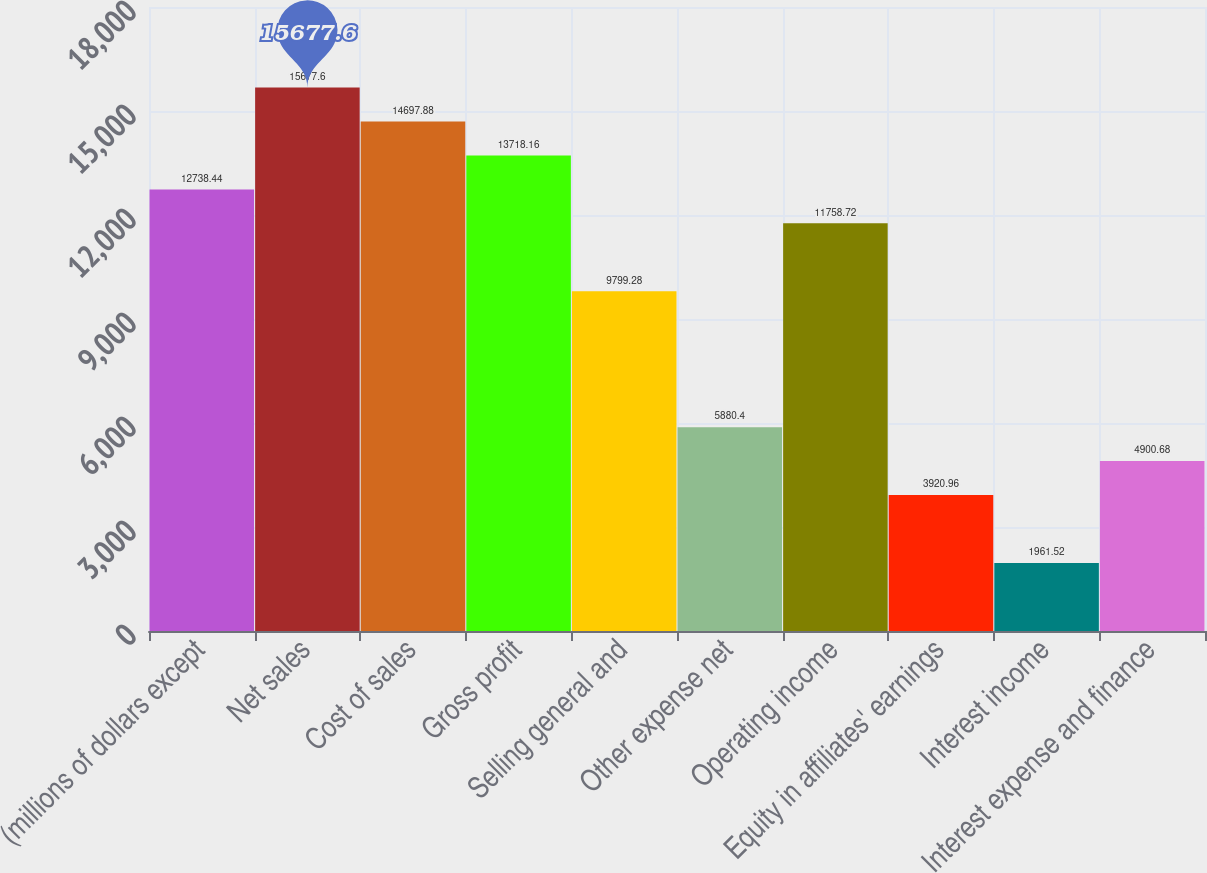Convert chart. <chart><loc_0><loc_0><loc_500><loc_500><bar_chart><fcel>(millions of dollars except<fcel>Net sales<fcel>Cost of sales<fcel>Gross profit<fcel>Selling general and<fcel>Other expense net<fcel>Operating income<fcel>Equity in affiliates' earnings<fcel>Interest income<fcel>Interest expense and finance<nl><fcel>12738.4<fcel>15677.6<fcel>14697.9<fcel>13718.2<fcel>9799.28<fcel>5880.4<fcel>11758.7<fcel>3920.96<fcel>1961.52<fcel>4900.68<nl></chart> 